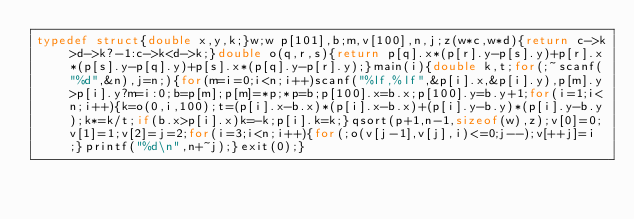<code> <loc_0><loc_0><loc_500><loc_500><_C_>typedef struct{double x,y,k;}w;w p[101],b;m,v[100],n,j;z(w*c,w*d){return c->k>d->k?-1:c->k<d->k;}double o(q,r,s){return p[q].x*(p[r].y-p[s].y)+p[r].x*(p[s].y-p[q].y)+p[s].x*(p[q].y-p[r].y);}main(i){double k,t;for(;~scanf("%d",&n),j=n;){for(m=i=0;i<n;i++)scanf("%lf,%lf",&p[i].x,&p[i].y),p[m].y>p[i].y?m=i:0;b=p[m];p[m]=*p;*p=b;p[100].x=b.x;p[100].y=b.y+1;for(i=1;i<n;i++){k=o(0,i,100);t=(p[i].x-b.x)*(p[i].x-b.x)+(p[i].y-b.y)*(p[i].y-b.y);k*=k/t;if(b.x>p[i].x)k=-k;p[i].k=k;}qsort(p+1,n-1,sizeof(w),z);v[0]=0;v[1]=1;v[2]=j=2;for(i=3;i<n;i++){for(;o(v[j-1],v[j],i)<=0;j--);v[++j]=i;}printf("%d\n",n+~j);}exit(0);}</code> 